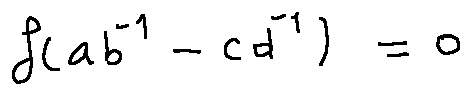Convert formula to latex. <formula><loc_0><loc_0><loc_500><loc_500>f ( a b ^ { - 1 } - c d ^ { - 1 } ) = 0</formula> 